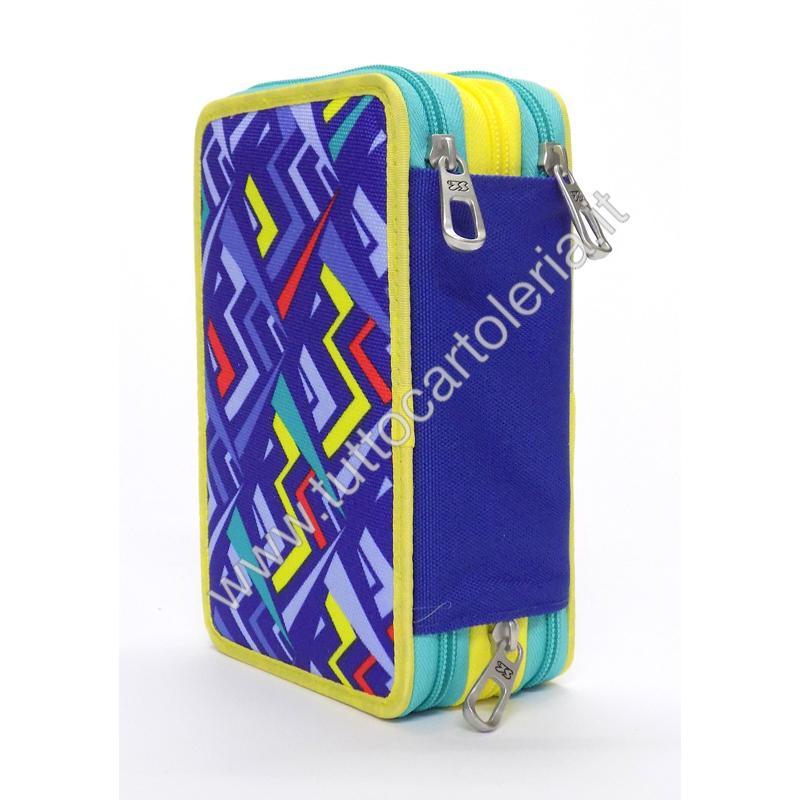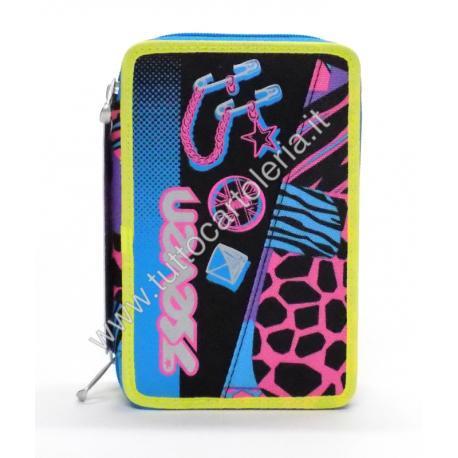The first image is the image on the left, the second image is the image on the right. Given the left and right images, does the statement "the left image shows two zippers on the pencil pouch top" hold true? Answer yes or no. Yes. The first image is the image on the left, the second image is the image on the right. Considering the images on both sides, is "The brand logo is visible on the outside of both pouches." valid? Answer yes or no. No. 